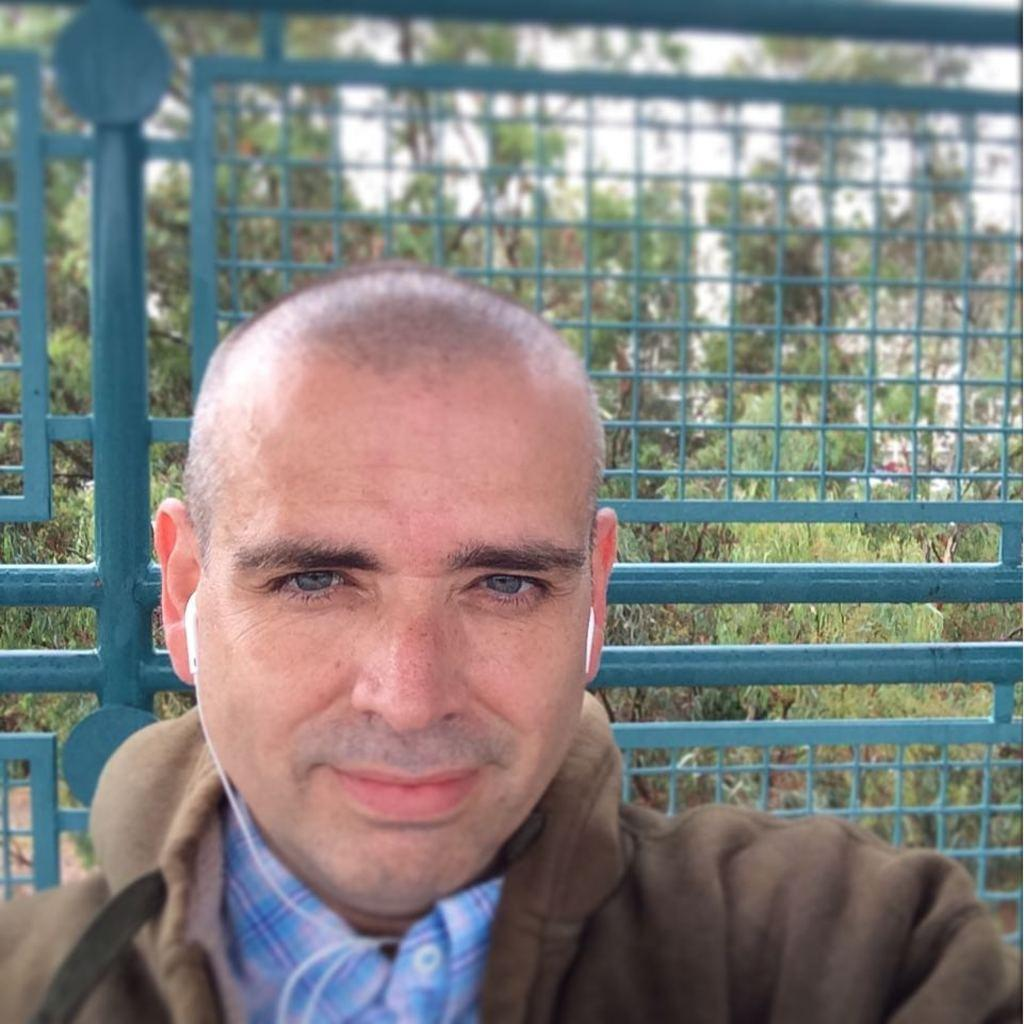Who is present in the image? There is a man in the image. What can be seen in the background of the image? There is a metal fence and a group of trees in the image. What part of the natural environment is visible in the image? The sky is visible in the image. What type of comfort can be seen in the room in the image? There is no room present in the image, as it features a man, a metal fence, a group of trees, and the sky. 